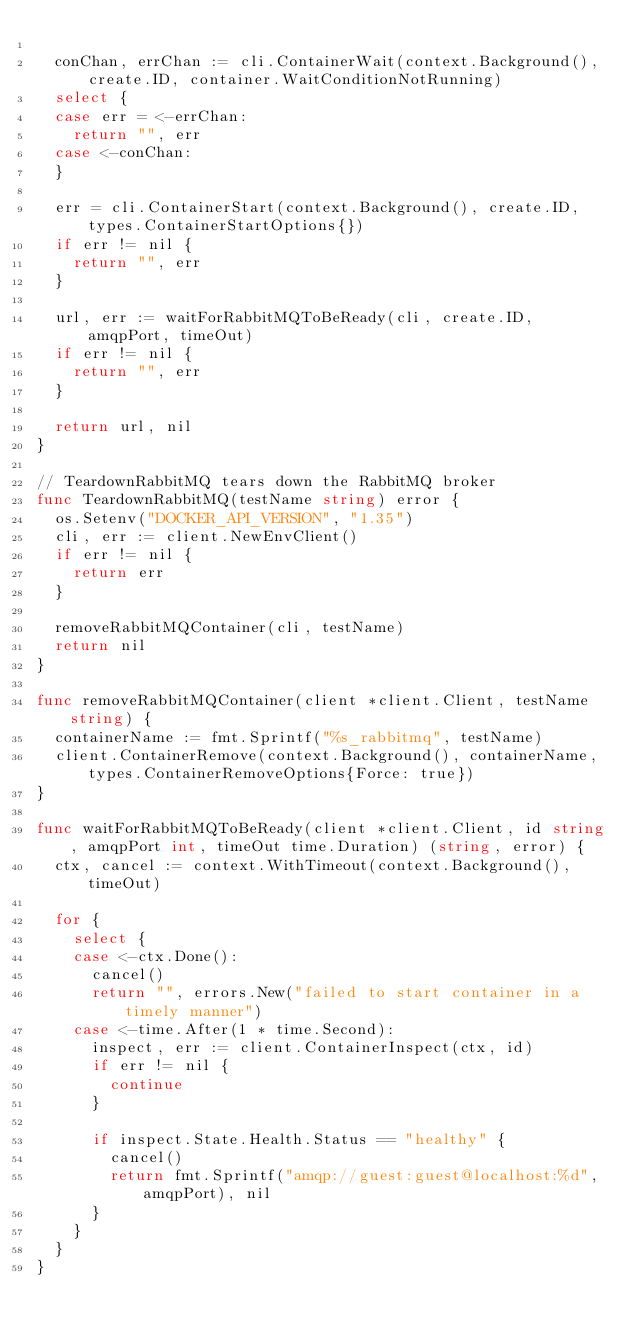Convert code to text. <code><loc_0><loc_0><loc_500><loc_500><_Go_>
	conChan, errChan := cli.ContainerWait(context.Background(), create.ID, container.WaitConditionNotRunning)
	select {
	case err = <-errChan:
		return "", err
	case <-conChan:
	}

	err = cli.ContainerStart(context.Background(), create.ID, types.ContainerStartOptions{})
	if err != nil {
		return "", err
	}

	url, err := waitForRabbitMQToBeReady(cli, create.ID, amqpPort, timeOut)
	if err != nil {
		return "", err
	}

	return url, nil
}

// TeardownRabbitMQ tears down the RabbitMQ broker
func TeardownRabbitMQ(testName string) error {
	os.Setenv("DOCKER_API_VERSION", "1.35")
	cli, err := client.NewEnvClient()
	if err != nil {
		return err
	}

	removeRabbitMQContainer(cli, testName)
	return nil
}

func removeRabbitMQContainer(client *client.Client, testName string) {
	containerName := fmt.Sprintf("%s_rabbitmq", testName)
	client.ContainerRemove(context.Background(), containerName, types.ContainerRemoveOptions{Force: true})
}

func waitForRabbitMQToBeReady(client *client.Client, id string, amqpPort int, timeOut time.Duration) (string, error) {
	ctx, cancel := context.WithTimeout(context.Background(), timeOut)

	for {
		select {
		case <-ctx.Done():
			cancel()
			return "", errors.New("failed to start container in a timely manner")
		case <-time.After(1 * time.Second):
			inspect, err := client.ContainerInspect(ctx, id)
			if err != nil {
				continue
			}

			if inspect.State.Health.Status == "healthy" {
				cancel()
				return fmt.Sprintf("amqp://guest:guest@localhost:%d", amqpPort), nil
			}
		}
	}
}
</code> 